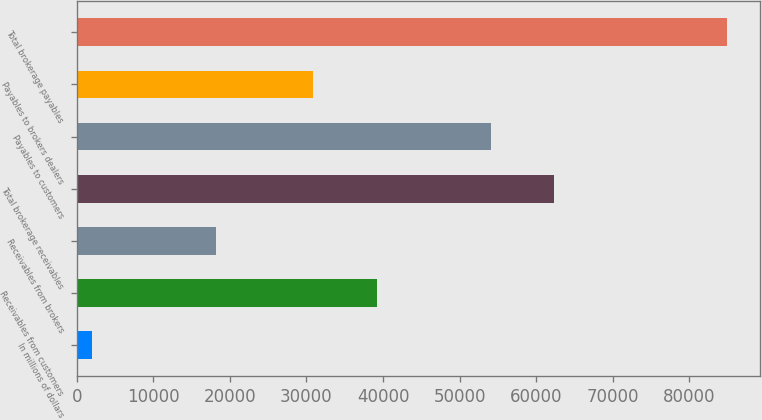Convert chart to OTSL. <chart><loc_0><loc_0><loc_500><loc_500><bar_chart><fcel>In millions of dollars<fcel>Receivables from customers<fcel>Receivables from brokers<fcel>Total brokerage receivables<fcel>Payables to customers<fcel>Payables to brokers dealers<fcel>Total brokerage payables<nl><fcel>2007<fcel>39207.4<fcel>18222<fcel>62332.4<fcel>54038<fcel>30913<fcel>84951<nl></chart> 